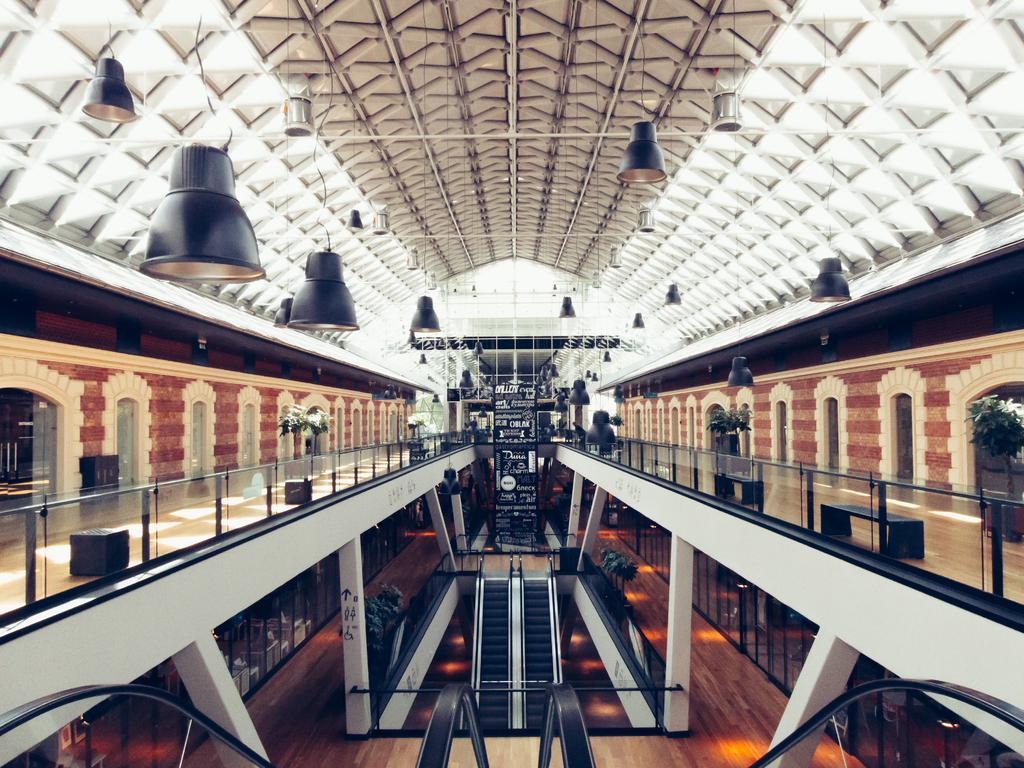What type of structure is present in the image? The image is taken in a building. What architectural feature can be seen in the image? There is a staircase, pillars, a wall, and a fence visible in the image. What type of plants are present in the image? House plants are present in the image. What type of lighting is present in the image? Lamps are hanged at the top of the image. What type of openings can be seen in the image? Windows are visible in the image. What type of shoe is visible on the staircase in the image? There is no shoe present on the staircase in the image. What type of station is depicted in the image? There is no station present in the image; it is taken in a building with various architectural features. 